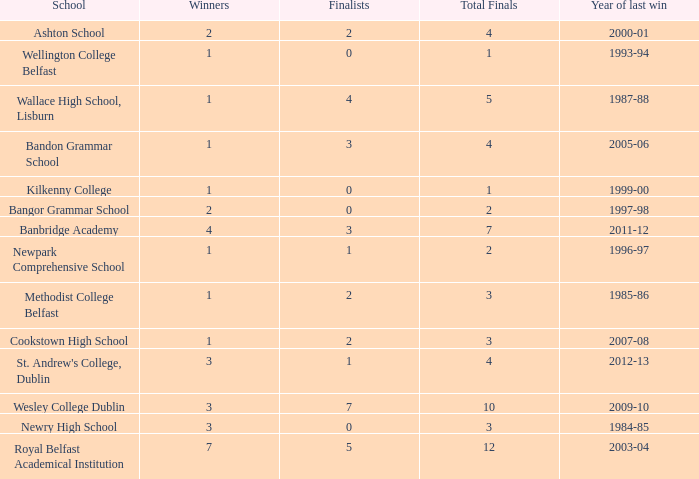What are the names that had a finalist score of 2? Ashton School, Cookstown High School, Methodist College Belfast. 